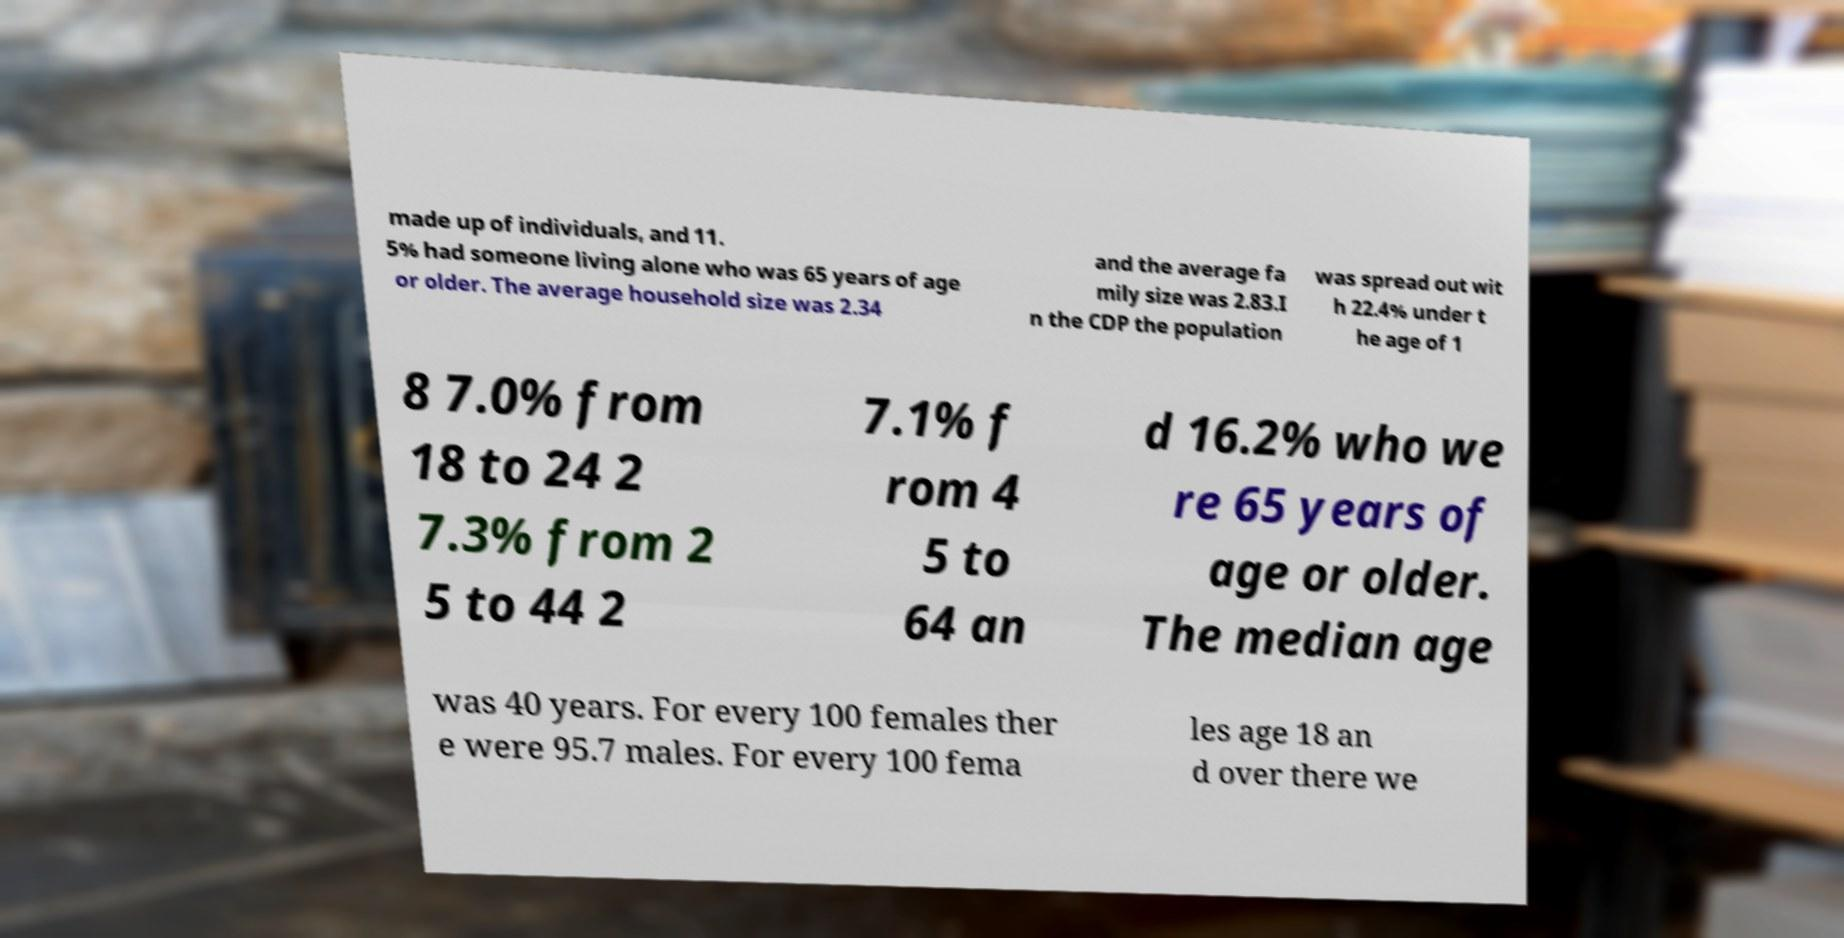There's text embedded in this image that I need extracted. Can you transcribe it verbatim? made up of individuals, and 11. 5% had someone living alone who was 65 years of age or older. The average household size was 2.34 and the average fa mily size was 2.83.I n the CDP the population was spread out wit h 22.4% under t he age of 1 8 7.0% from 18 to 24 2 7.3% from 2 5 to 44 2 7.1% f rom 4 5 to 64 an d 16.2% who we re 65 years of age or older. The median age was 40 years. For every 100 females ther e were 95.7 males. For every 100 fema les age 18 an d over there we 